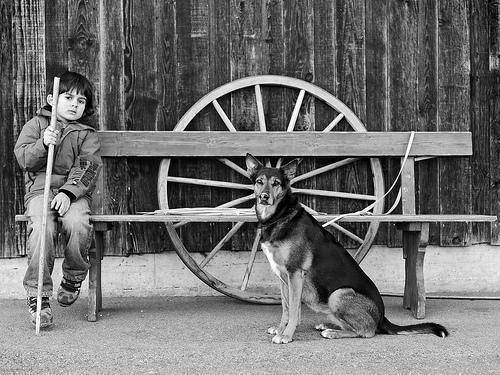How many dogs are pictured?
Give a very brief answer. 1. 